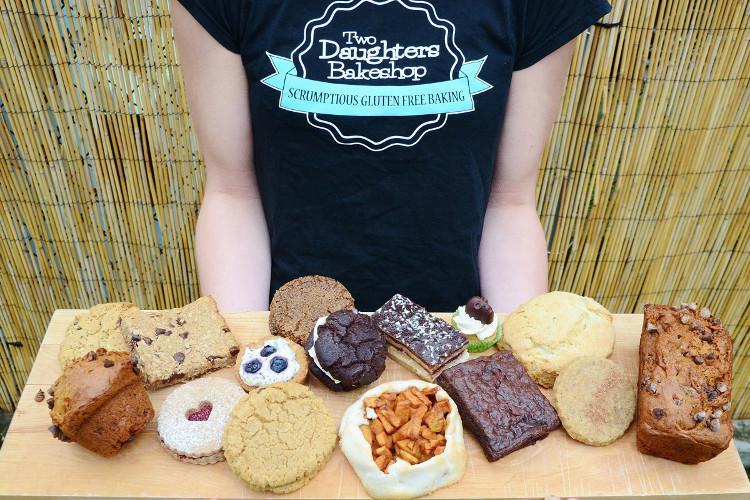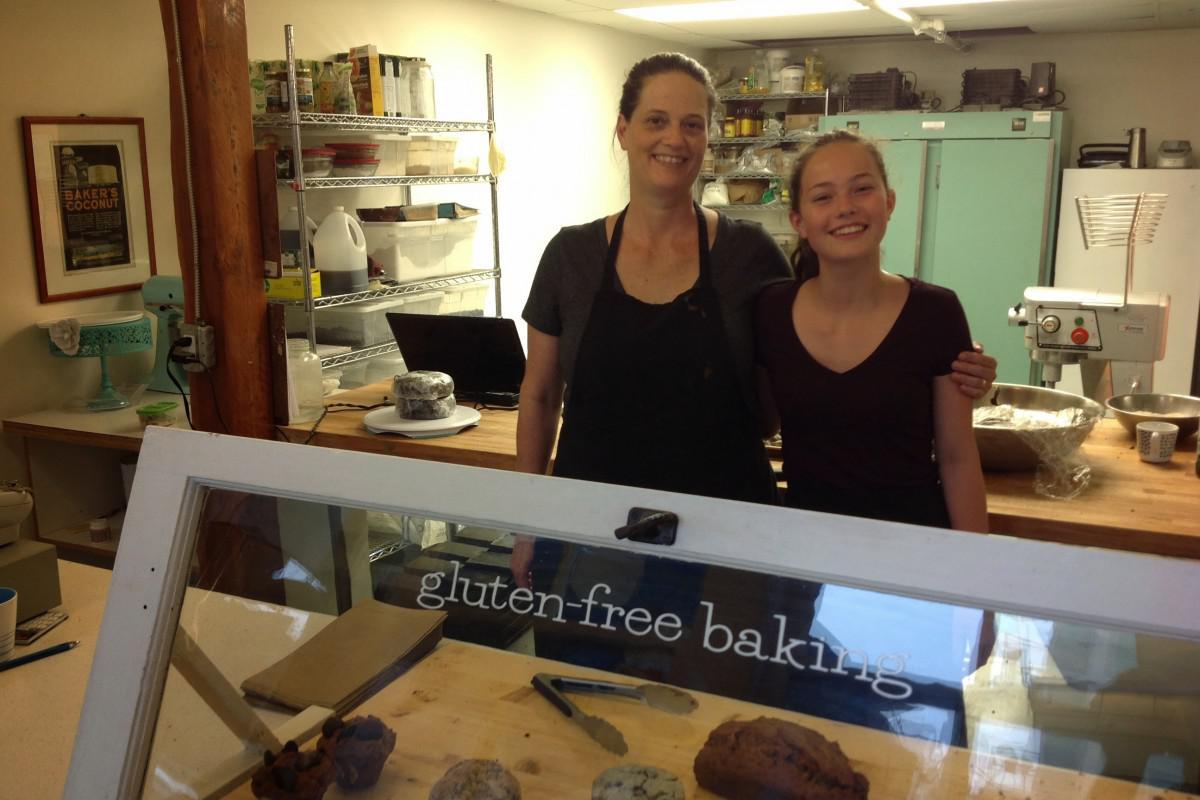The first image is the image on the left, the second image is the image on the right. Considering the images on both sides, is "The image on the left shows desserts in the foreground and exactly three people." valid? Answer yes or no. No. The first image is the image on the left, the second image is the image on the right. Analyze the images presented: Is the assertion "One image includes a girl at least on the right of an adult woman, and they are standing behind a rectangle of glass." valid? Answer yes or no. Yes. 